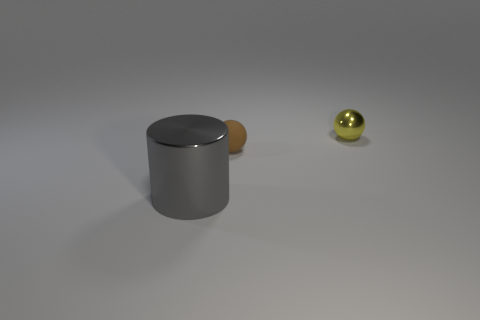Add 2 gray objects. How many objects exist? 5 Subtract all spheres. How many objects are left? 1 Add 2 tiny yellow metal cubes. How many tiny yellow metal cubes exist? 2 Subtract 0 green cylinders. How many objects are left? 3 Subtract all tiny yellow shiny cubes. Subtract all tiny metallic objects. How many objects are left? 2 Add 2 gray shiny things. How many gray shiny things are left? 3 